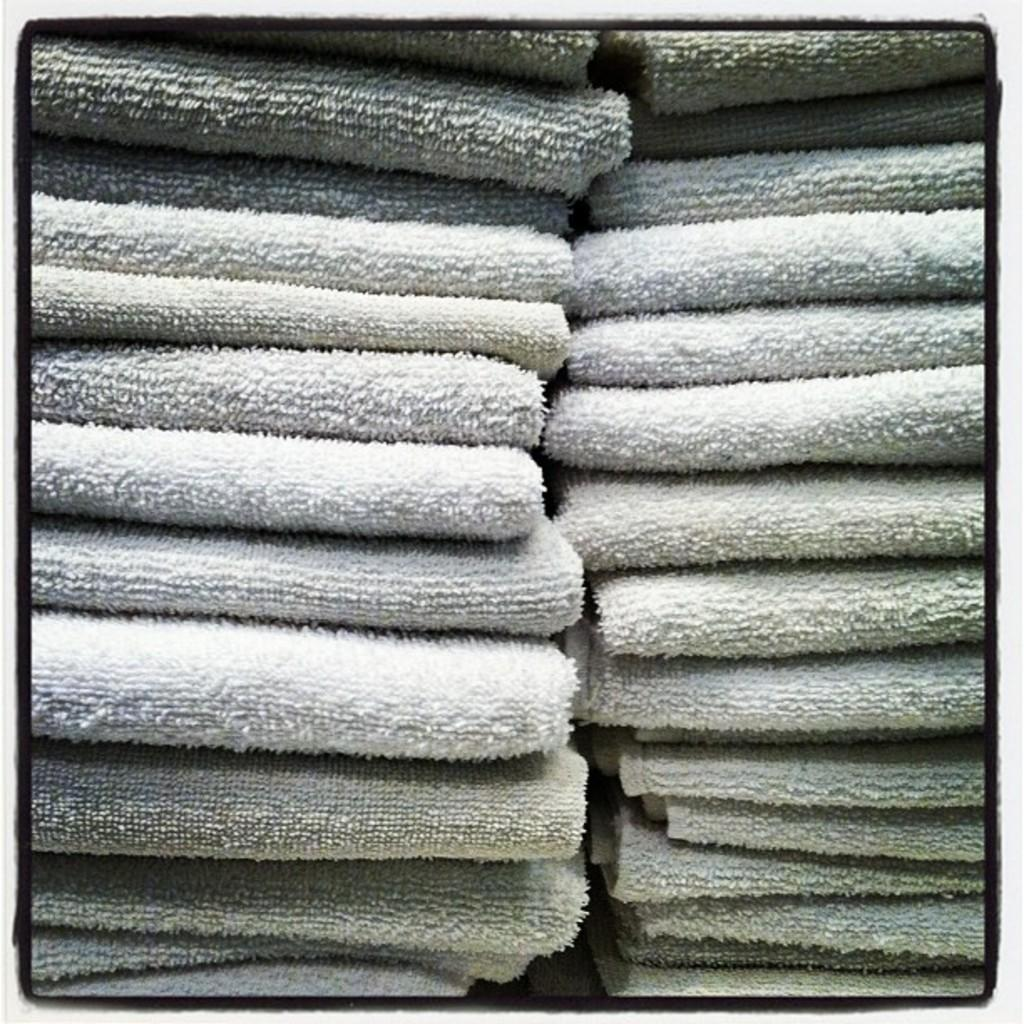What objects are present in the image? There are towels in the image. How are the towels arranged in the image? The towels are folded. Reasoning: Let' Let's think step by step in order to produce the conversation. We start by identifying the main subject in the image, which is the towels. Then, we describe their arrangement, which is folded. We avoid yes/no questions and ensure that the language is simple and clear. Absurd Question/Answer: What type of ice can be seen melting on the towels in the image? There is no ice present in the image; it only features folded towels. Is there a fight happening between the towels in the image? No, there is no fight depicted in the image; it only features folded towels. 